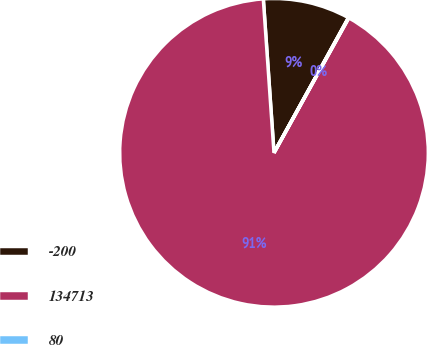Convert chart to OTSL. <chart><loc_0><loc_0><loc_500><loc_500><pie_chart><fcel>-200<fcel>134713<fcel>80<nl><fcel>9.12%<fcel>90.85%<fcel>0.04%<nl></chart> 